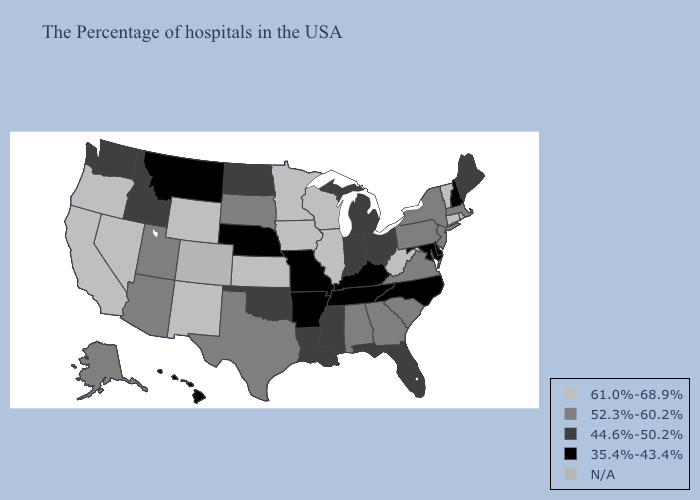Name the states that have a value in the range 52.3%-60.2%?
Be succinct. Massachusetts, New York, New Jersey, Pennsylvania, Virginia, South Carolina, Georgia, Alabama, Texas, South Dakota, Utah, Arizona, Alaska. What is the highest value in states that border Minnesota?
Quick response, please. 61.0%-68.9%. What is the lowest value in the South?
Concise answer only. 35.4%-43.4%. Name the states that have a value in the range 61.0%-68.9%?
Give a very brief answer. Rhode Island, Vermont, Connecticut, West Virginia, Wisconsin, Illinois, Minnesota, Iowa, Kansas, Wyoming, New Mexico, Nevada, California, Oregon. What is the value of Montana?
Write a very short answer. 35.4%-43.4%. Does Montana have the lowest value in the USA?
Concise answer only. Yes. Name the states that have a value in the range 44.6%-50.2%?
Concise answer only. Maine, Ohio, Florida, Michigan, Indiana, Mississippi, Louisiana, Oklahoma, North Dakota, Idaho, Washington. What is the highest value in the USA?
Keep it brief. 61.0%-68.9%. Which states have the lowest value in the USA?
Give a very brief answer. New Hampshire, Delaware, Maryland, North Carolina, Kentucky, Tennessee, Missouri, Arkansas, Nebraska, Montana, Hawaii. What is the value of Illinois?
Be succinct. 61.0%-68.9%. Name the states that have a value in the range 61.0%-68.9%?
Write a very short answer. Rhode Island, Vermont, Connecticut, West Virginia, Wisconsin, Illinois, Minnesota, Iowa, Kansas, Wyoming, New Mexico, Nevada, California, Oregon. Does Virginia have the highest value in the USA?
Write a very short answer. No. What is the highest value in the USA?
Concise answer only. 61.0%-68.9%. What is the value of North Carolina?
Keep it brief. 35.4%-43.4%. 